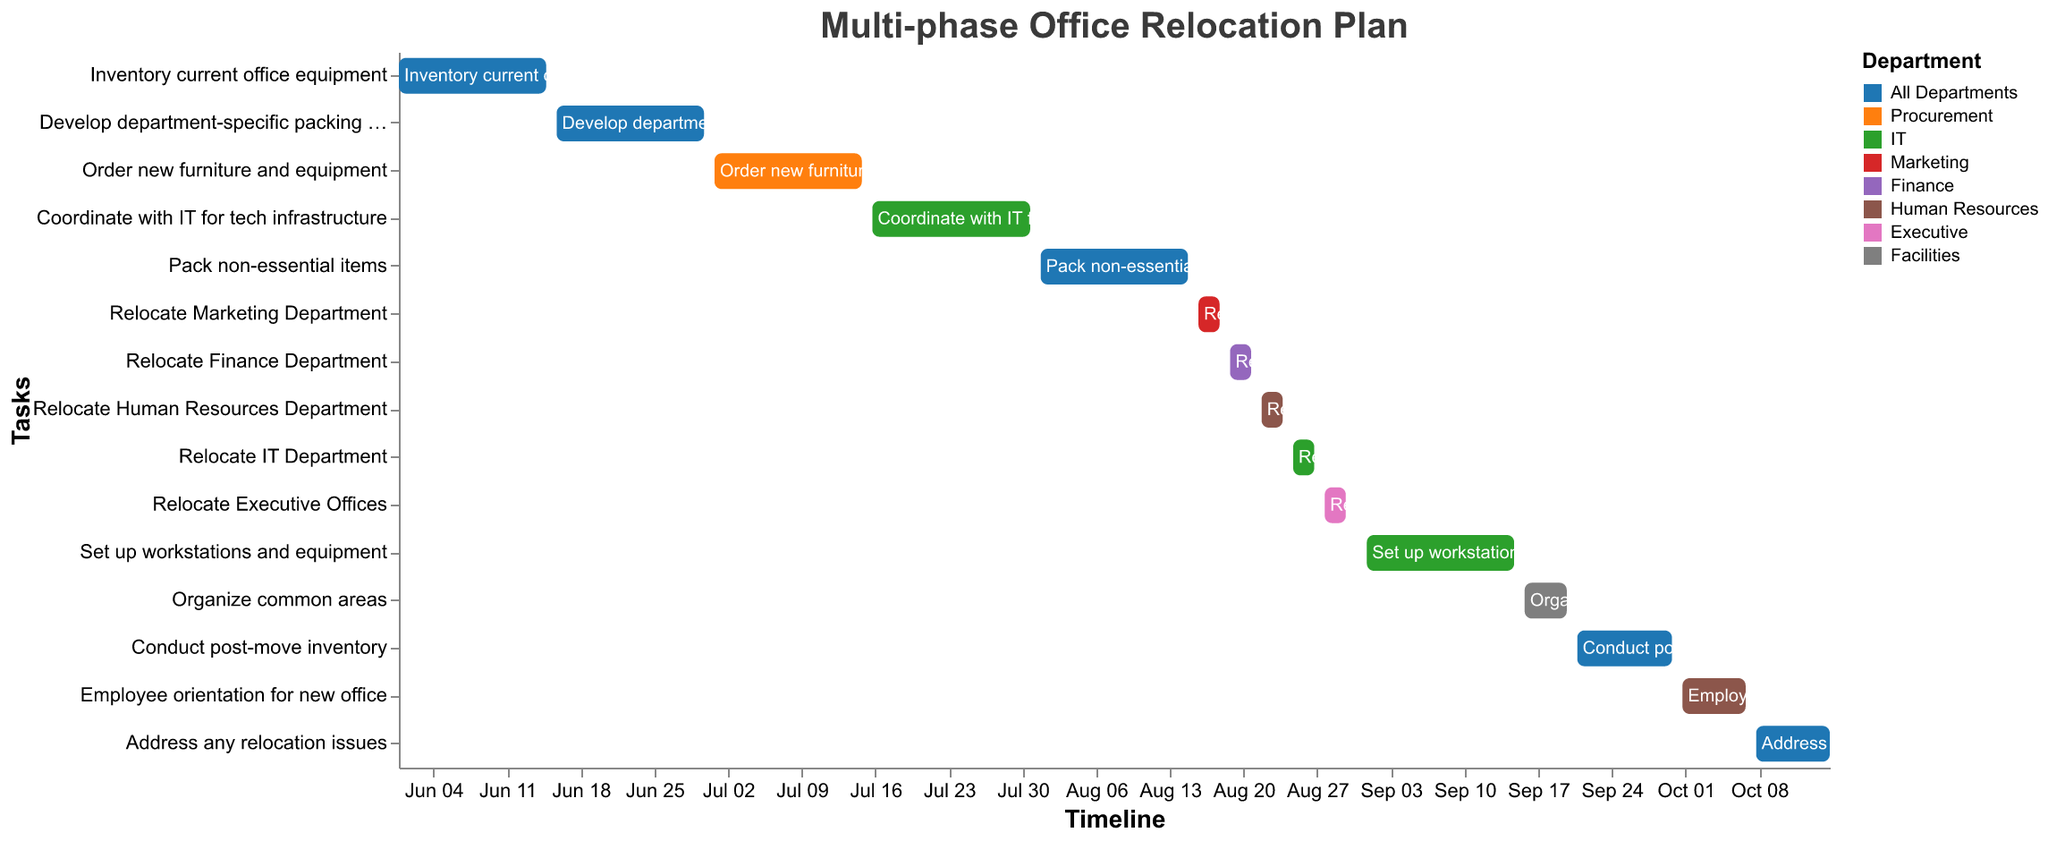What is the title of the Gantt Chart? The title is usually placed at the top of the chart. Here, it reads "Multi-phase Office Relocation Plan".
Answer: Multi-phase Office Relocation Plan Which department is responsible for ordering new furniture and equipment? The color representing the Procurement department in the legend matches the color associated with the task "Order new furniture and equipment".
Answer: Procurement How long is the entire relocation process from the beginning to the end? The first task starts on 2023-06-01 and the last task ends on 2023-10-15. Calculate the total duration by subtracting the start date from the end date.
Answer: 137 days Which department has the most tasks during the relocation process? By counting the tasks assigned to each department, we see that "All Departments" has the most tasks listed in the chart.
Answer: All Departments When does the IT department start setting up workstations and equipment? Locate the task "Set up workstations and equipment" and refer to its start date. The Gantt chart indicates it starts on 2023-09-01.
Answer: 2023-09-01 Which tasks are scheduled to be conducted in September? Identify the tasks within the date range of 2023-09-01 to 2023-09-30. These tasks are "Set up workstations and equipment", "Organize common areas", and "Conduct post-move inventory".
Answer: Set up workstations and equipment, Organize common areas, Conduct post-move inventory How many days does it take to pack non-essential items? Refer to the "Pack non-essential items" task. The start date is 2023-08-01, and the end date is 2023-08-15. Subtract the start date from the end date.
Answer: 15 days Which department relocates their offices last? Check the last relocation task, and identify the associated department. The task "Relocate Executive Offices" is the last in the relocation sequence.
Answer: Executive Compare the start and end dates of the tasks "Employee orientation for new office" and "Address any relocation issues". Which one finishes later? "Employee orientation for new office" ends on 2023-10-07, and "Address any relocation issues" ends on 2023-10-15. By comparing these dates, the latter task ends later.
Answer: Address any relocation issues 